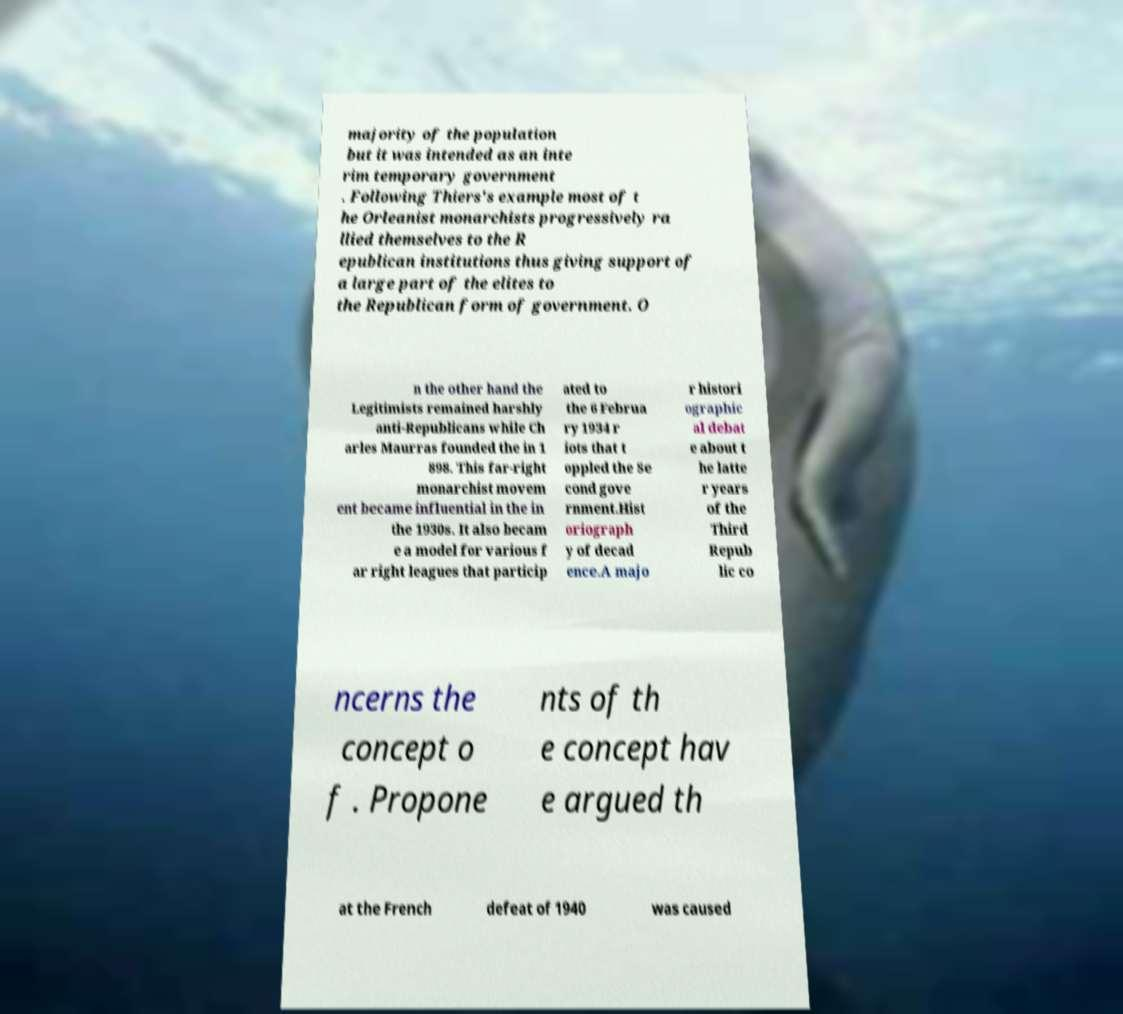Can you read and provide the text displayed in the image?This photo seems to have some interesting text. Can you extract and type it out for me? majority of the population but it was intended as an inte rim temporary government . Following Thiers's example most of t he Orleanist monarchists progressively ra llied themselves to the R epublican institutions thus giving support of a large part of the elites to the Republican form of government. O n the other hand the Legitimists remained harshly anti-Republicans while Ch arles Maurras founded the in 1 898. This far-right monarchist movem ent became influential in the in the 1930s. It also becam e a model for various f ar right leagues that particip ated to the 6 Februa ry 1934 r iots that t oppled the Se cond gove rnment.Hist oriograph y of decad ence.A majo r histori ographic al debat e about t he latte r years of the Third Repub lic co ncerns the concept o f . Propone nts of th e concept hav e argued th at the French defeat of 1940 was caused 